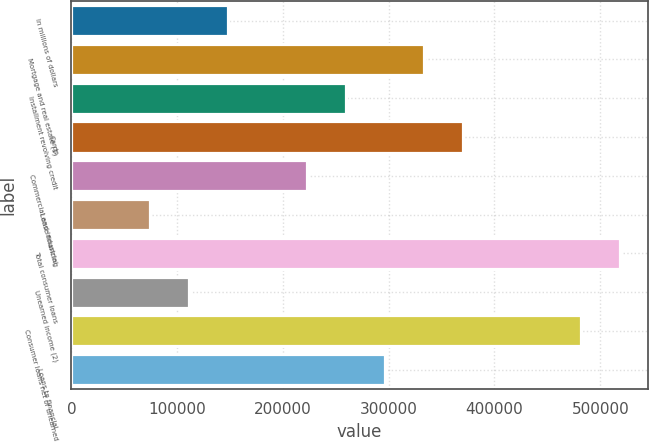Convert chart to OTSL. <chart><loc_0><loc_0><loc_500><loc_500><bar_chart><fcel>In millions of dollars<fcel>Mortgage and real estate (1)<fcel>Installment revolving credit<fcel>Cards<fcel>Commercial and industrial<fcel>Lease financing<fcel>Total consumer loans<fcel>Unearned income (2)<fcel>Consumer loans net of unearned<fcel>Loans to financial<nl><fcel>148262<fcel>333587<fcel>259457<fcel>370652<fcel>222392<fcel>74132.4<fcel>518912<fcel>111197<fcel>481847<fcel>296522<nl></chart> 